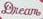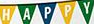What text appears in these images from left to right, separated by a semicolon? Dream; HAPPY 